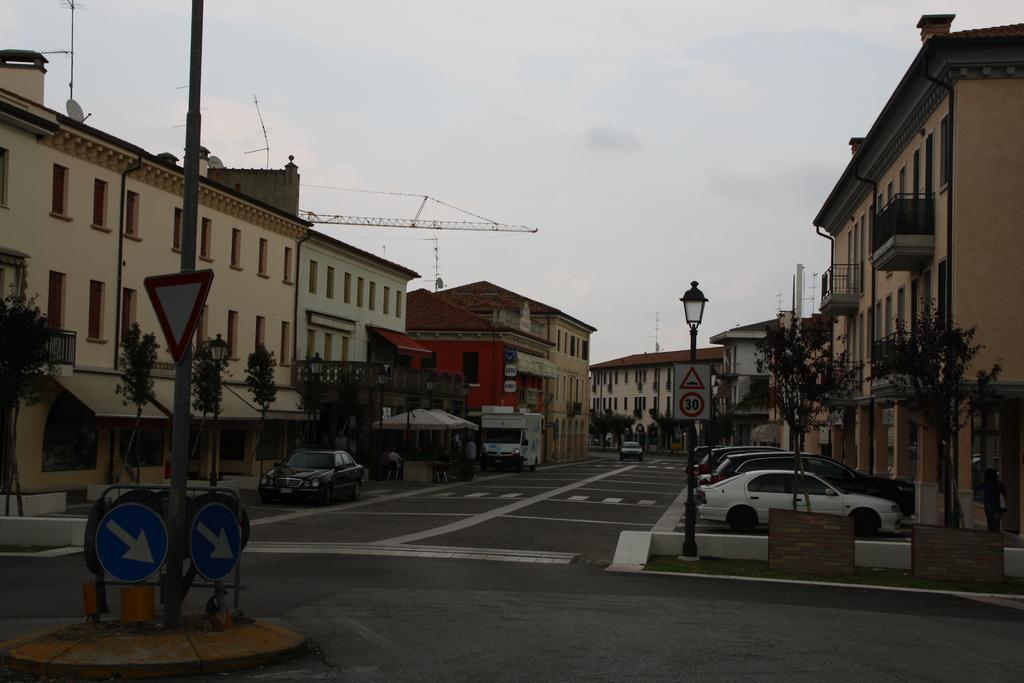What can be seen parked on the road in the image? There are vehicles parked on the road in the image. What type of natural elements are visible in the image? Trees are visible in the image. What type of informational signs are present in the image? Signboards are present in the image. What type of lighting is present in the image? There are lights attached to poles in the image. What type of man-made structures are visible in the image? Buildings are visible in the image. What type of communication devices are present in the image? Antennas are present in the image. What part of the natural environment is visible in the background of the image? The sky is visible in the background of the image. Can you tell me how many times the statement "I love you" is repeated in the image? There is no statement or text present in the image, so it is not possible to determine how many times the phrase "I love you" is repeated. How does the person in the image kick the ball? There is no person or ball present in the image, so it is not possible to describe any kicking action. 